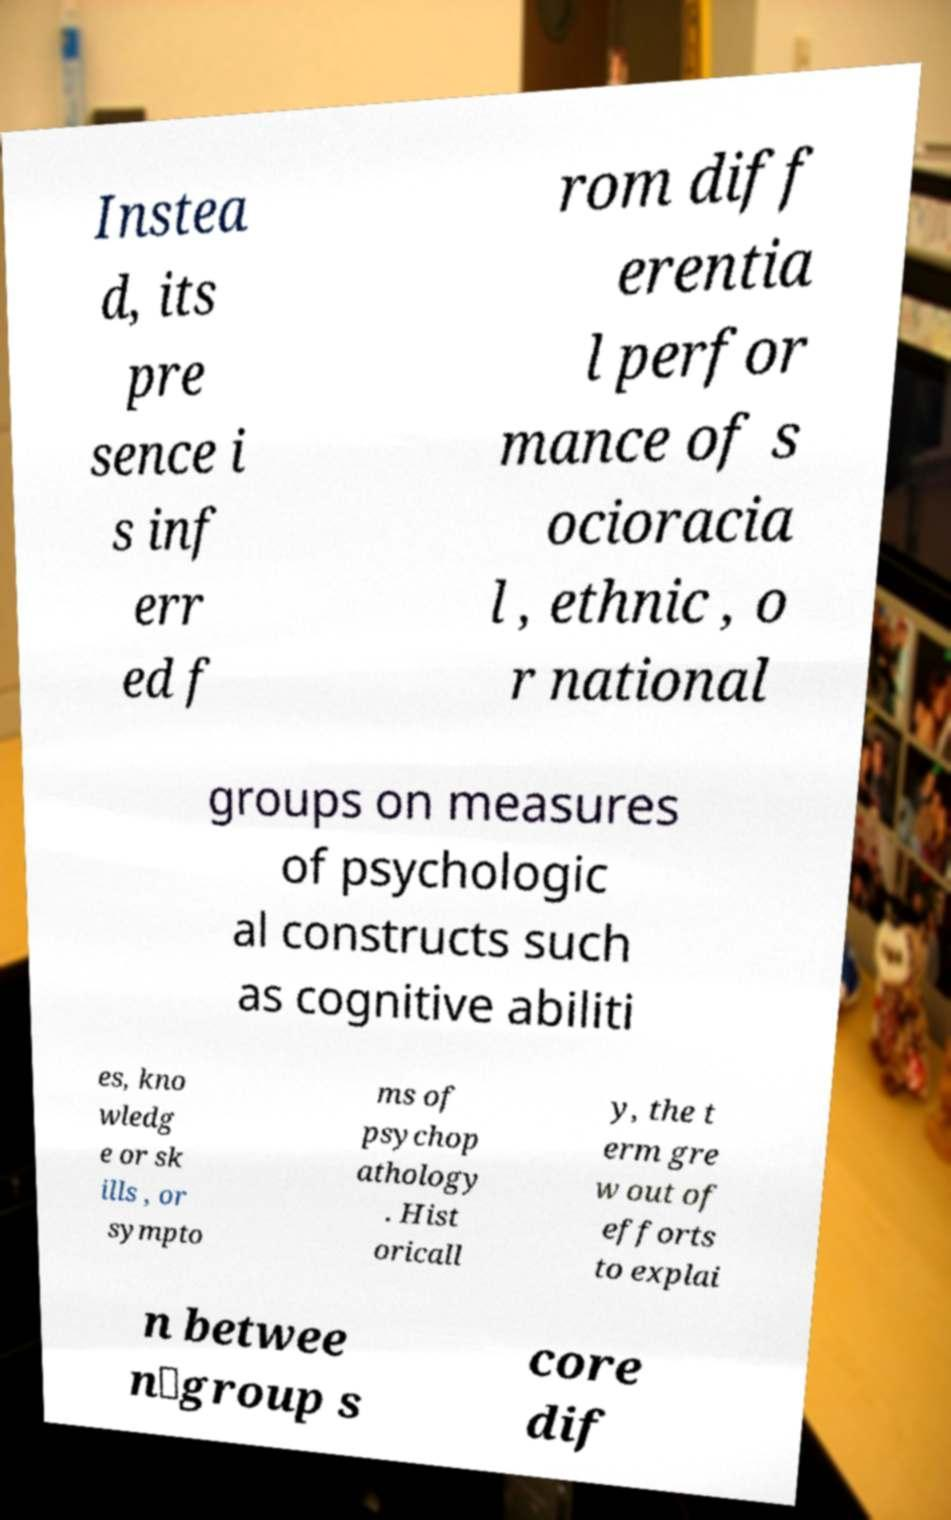Could you extract and type out the text from this image? Instea d, its pre sence i s inf err ed f rom diff erentia l perfor mance of s ocioracia l , ethnic , o r national groups on measures of psychologic al constructs such as cognitive abiliti es, kno wledg e or sk ills , or sympto ms of psychop athology . Hist oricall y, the t erm gre w out of efforts to explai n betwee n‐group s core dif 